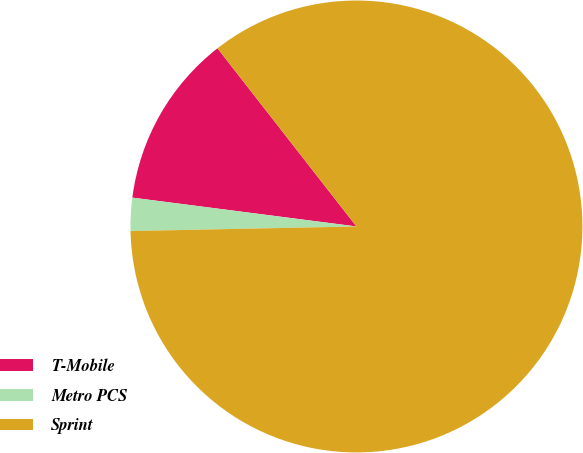Convert chart. <chart><loc_0><loc_0><loc_500><loc_500><pie_chart><fcel>T-Mobile<fcel>Metro PCS<fcel>Sprint<nl><fcel>12.42%<fcel>2.36%<fcel>85.22%<nl></chart> 